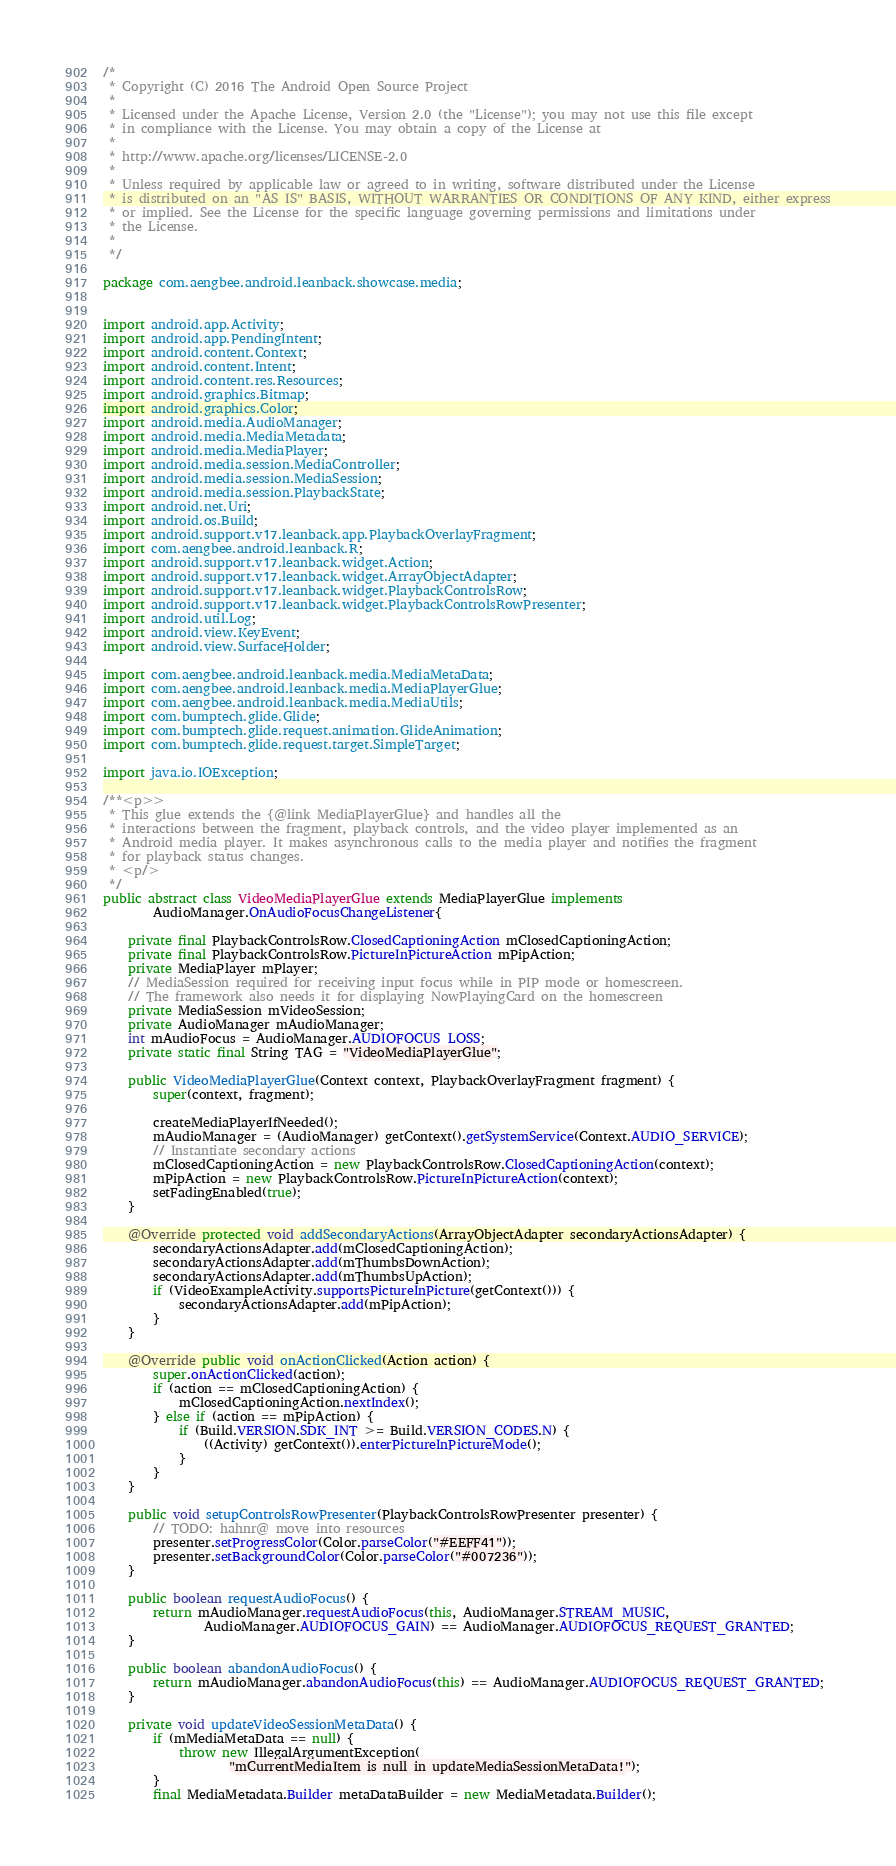Convert code to text. <code><loc_0><loc_0><loc_500><loc_500><_Java_>/*
 * Copyright (C) 2016 The Android Open Source Project
 *
 * Licensed under the Apache License, Version 2.0 (the "License"); you may not use this file except
 * in compliance with the License. You may obtain a copy of the License at
 *
 * http://www.apache.org/licenses/LICENSE-2.0
 *
 * Unless required by applicable law or agreed to in writing, software distributed under the License
 * is distributed on an "AS IS" BASIS, WITHOUT WARRANTIES OR CONDITIONS OF ANY KIND, either express
 * or implied. See the License for the specific language governing permissions and limitations under
 * the License.
 *
 */

package com.aengbee.android.leanback.showcase.media;


import android.app.Activity;
import android.app.PendingIntent;
import android.content.Context;
import android.content.Intent;
import android.content.res.Resources;
import android.graphics.Bitmap;
import android.graphics.Color;
import android.media.AudioManager;
import android.media.MediaMetadata;
import android.media.MediaPlayer;
import android.media.session.MediaController;
import android.media.session.MediaSession;
import android.media.session.PlaybackState;
import android.net.Uri;
import android.os.Build;
import android.support.v17.leanback.app.PlaybackOverlayFragment;
import com.aengbee.android.leanback.R;
import android.support.v17.leanback.widget.Action;
import android.support.v17.leanback.widget.ArrayObjectAdapter;
import android.support.v17.leanback.widget.PlaybackControlsRow;
import android.support.v17.leanback.widget.PlaybackControlsRowPresenter;
import android.util.Log;
import android.view.KeyEvent;
import android.view.SurfaceHolder;

import com.aengbee.android.leanback.media.MediaMetaData;
import com.aengbee.android.leanback.media.MediaPlayerGlue;
import com.aengbee.android.leanback.media.MediaUtils;
import com.bumptech.glide.Glide;
import com.bumptech.glide.request.animation.GlideAnimation;
import com.bumptech.glide.request.target.SimpleTarget;

import java.io.IOException;

/**<p>>
 * This glue extends the {@link MediaPlayerGlue} and handles all the
 * interactions between the fragment, playback controls, and the video player implemented as an
 * Android media player. It makes asynchronous calls to the media player and notifies the fragment
 * for playback status changes.
 * <p/>
 */
public abstract class VideoMediaPlayerGlue extends MediaPlayerGlue implements
        AudioManager.OnAudioFocusChangeListener{

    private final PlaybackControlsRow.ClosedCaptioningAction mClosedCaptioningAction;
    private final PlaybackControlsRow.PictureInPictureAction mPipAction;
    private MediaPlayer mPlayer;
    // MediaSession required for receiving input focus while in PIP mode or homescreen.
    // The framework also needs it for displaying NowPlayingCard on the homescreen
    private MediaSession mVideoSession;
    private AudioManager mAudioManager;
    int mAudioFocus = AudioManager.AUDIOFOCUS_LOSS;
    private static final String TAG = "VideoMediaPlayerGlue";

    public VideoMediaPlayerGlue(Context context, PlaybackOverlayFragment fragment) {
        super(context, fragment);

        createMediaPlayerIfNeeded();
        mAudioManager = (AudioManager) getContext().getSystemService(Context.AUDIO_SERVICE);
        // Instantiate secondary actions
        mClosedCaptioningAction = new PlaybackControlsRow.ClosedCaptioningAction(context);
        mPipAction = new PlaybackControlsRow.PictureInPictureAction(context);
        setFadingEnabled(true);
    }

    @Override protected void addSecondaryActions(ArrayObjectAdapter secondaryActionsAdapter) {
        secondaryActionsAdapter.add(mClosedCaptioningAction);
        secondaryActionsAdapter.add(mThumbsDownAction);
        secondaryActionsAdapter.add(mThumbsUpAction);
        if (VideoExampleActivity.supportsPictureInPicture(getContext())) {
            secondaryActionsAdapter.add(mPipAction);
        }
    }

    @Override public void onActionClicked(Action action) {
        super.onActionClicked(action);
        if (action == mClosedCaptioningAction) {
            mClosedCaptioningAction.nextIndex();
        } else if (action == mPipAction) {
            if (Build.VERSION.SDK_INT >= Build.VERSION_CODES.N) {
                ((Activity) getContext()).enterPictureInPictureMode();
            }
        }
    }

    public void setupControlsRowPresenter(PlaybackControlsRowPresenter presenter) {
        // TODO: hahnr@ move into resources
        presenter.setProgressColor(Color.parseColor("#EEFF41"));
        presenter.setBackgroundColor(Color.parseColor("#007236"));
    }

    public boolean requestAudioFocus() {
        return mAudioManager.requestAudioFocus(this, AudioManager.STREAM_MUSIC,
                AudioManager.AUDIOFOCUS_GAIN) == AudioManager.AUDIOFOCUS_REQUEST_GRANTED;
    }

    public boolean abandonAudioFocus() {
        return mAudioManager.abandonAudioFocus(this) == AudioManager.AUDIOFOCUS_REQUEST_GRANTED;
    }

    private void updateVideoSessionMetaData() {
        if (mMediaMetaData == null) {
            throw new IllegalArgumentException(
                    "mCurrentMediaItem is null in updateMediaSessionMetaData!");
        }
        final MediaMetadata.Builder metaDataBuilder = new MediaMetadata.Builder();</code> 